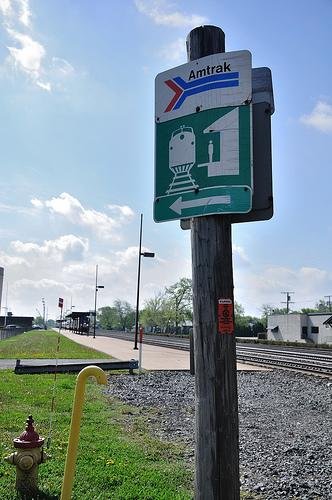Summarize the main features of the image in a single sentence. The image features a wooden signpost with various signs, a train platform, a fire hydrant, and a row of lamp posts near train tracks. List the most prominent objects present in the image. Wooden signpost, train tracks, fire hydrant, paved platform, lamp posts, small shelter, amtrak train sign, yellow pipe. Mention the colors and shapes of some primary objects in the image. Red sign on a wooden post, green and white rectangular sign, white arrow shape pointing left, black Amtrak lettering on a white sign, blue and red circular symbol, and red and yellow fire hydrant. Write a brief narrative about the scene depicted in the image. Amidst a backdrop of train tracks and a paved platform, a wooden signpost laden with numerous signs stands tall, as a fire hydrant, a small shelter, and a row of lamp posts find their place near the bustling railway activity. Point out any distinctive elements or features of the image. The wooden signpost with various signs, a uniquely crooked yellow pole, and the Amtrak train sign distinguish this image as a railway station with different elements combined for functionality and aesthetics. Write a sentence describing any potential activities that might occur in this scene. Passengers could be waiting at the small shelter for trains, while signage on the wooden post and Amtrak sign provides information on train routes and schedules. Provide a description of the central object in the image and its surroundings. A wooden signpost with multiple signs attached is located on a paved platform near a set of train tracks, and a row of lamp posts and a small shelter for train passengers. Describe any potential hazards or safety measures present in the image. A red and yellow fire hydrant is available as a safety measure, while a yellow pipe in the ground and metal barricade fence might pose potential hazards near the train tracks. Describe the setting where this image might have been taken. The image is likely captured at an Amtrak train station with multiple signs on a signpost, train tracks, lamp posts, a fire hydrant, a shelter, and a paved platform in the vicinity. Describe any landscape elements in the image. A strip of green grass, a line of trees turning green, and white fluffy clouds are the landscape elements amidst the train station setting in the image. 